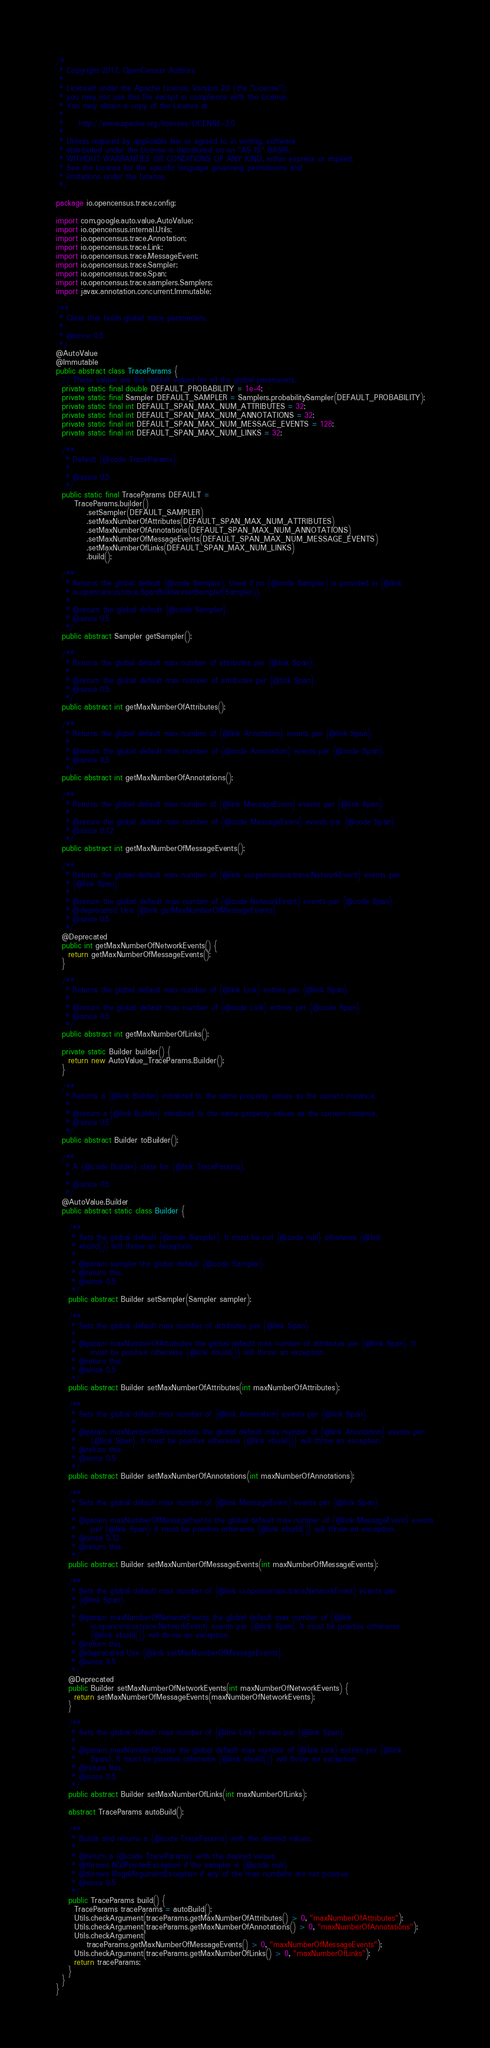<code> <loc_0><loc_0><loc_500><loc_500><_Java_>/*
 * Copyright 2017, OpenCensus Authors
 *
 * Licensed under the Apache License, Version 2.0 (the "License");
 * you may not use this file except in compliance with the License.
 * You may obtain a copy of the License at
 *
 *     http://www.apache.org/licenses/LICENSE-2.0
 *
 * Unless required by applicable law or agreed to in writing, software
 * distributed under the License is distributed on an "AS IS" BASIS,
 * WITHOUT WARRANTIES OR CONDITIONS OF ANY KIND, either express or implied.
 * See the License for the specific language governing permissions and
 * limitations under the License.
 */

package io.opencensus.trace.config;

import com.google.auto.value.AutoValue;
import io.opencensus.internal.Utils;
import io.opencensus.trace.Annotation;
import io.opencensus.trace.Link;
import io.opencensus.trace.MessageEvent;
import io.opencensus.trace.Sampler;
import io.opencensus.trace.Span;
import io.opencensus.trace.samplers.Samplers;
import javax.annotation.concurrent.Immutable;

/**
 * Class that holds global trace parameters.
 *
 * @since 0.5
 */
@AutoValue
@Immutable
public abstract class TraceParams {
  // These values are the default values for all the global parameters.
  private static final double DEFAULT_PROBABILITY = 1e-4;
  private static final Sampler DEFAULT_SAMPLER = Samplers.probabilitySampler(DEFAULT_PROBABILITY);
  private static final int DEFAULT_SPAN_MAX_NUM_ATTRIBUTES = 32;
  private static final int DEFAULT_SPAN_MAX_NUM_ANNOTATIONS = 32;
  private static final int DEFAULT_SPAN_MAX_NUM_MESSAGE_EVENTS = 128;
  private static final int DEFAULT_SPAN_MAX_NUM_LINKS = 32;

  /**
   * Default {@code TraceParams}.
   *
   * @since 0.5
   */
  public static final TraceParams DEFAULT =
      TraceParams.builder()
          .setSampler(DEFAULT_SAMPLER)
          .setMaxNumberOfAttributes(DEFAULT_SPAN_MAX_NUM_ATTRIBUTES)
          .setMaxNumberOfAnnotations(DEFAULT_SPAN_MAX_NUM_ANNOTATIONS)
          .setMaxNumberOfMessageEvents(DEFAULT_SPAN_MAX_NUM_MESSAGE_EVENTS)
          .setMaxNumberOfLinks(DEFAULT_SPAN_MAX_NUM_LINKS)
          .build();

  /**
   * Returns the global default {@code Sampler}. Used if no {@code Sampler} is provided in {@link
   * io.opencensus.trace.SpanBuilder#setSampler(Sampler)}.
   *
   * @return the global default {@code Sampler}.
   * @since 0.5
   */
  public abstract Sampler getSampler();

  /**
   * Returns the global default max number of attributes per {@link Span}.
   *
   * @return the global default max number of attributes per {@link Span}.
   * @since 0.5
   */
  public abstract int getMaxNumberOfAttributes();

  /**
   * Returns the global default max number of {@link Annotation} events per {@link Span}.
   *
   * @return the global default max number of {@code Annotation} events per {@code Span}.
   * @since 0.5
   */
  public abstract int getMaxNumberOfAnnotations();

  /**
   * Returns the global default max number of {@link MessageEvent} events per {@link Span}.
   *
   * @return the global default max number of {@code MessageEvent} events per {@code Span}.
   * @since 0.12
   */
  public abstract int getMaxNumberOfMessageEvents();

  /**
   * Returns the global default max number of {@link io.opencensus.trace.NetworkEvent} events per
   * {@link Span}.
   *
   * @return the global default max number of {@code NetworkEvent} events per {@code Span}.
   * @deprecated Use {@link getMaxNumberOfMessageEvents}.
   * @since 0.5
   */
  @Deprecated
  public int getMaxNumberOfNetworkEvents() {
    return getMaxNumberOfMessageEvents();
  }

  /**
   * Returns the global default max number of {@link Link} entries per {@link Span}.
   *
   * @return the global default max number of {@code Link} entries per {@code Span}.
   * @since 0.5
   */
  public abstract int getMaxNumberOfLinks();

  private static Builder builder() {
    return new AutoValue_TraceParams.Builder();
  }

  /**
   * Returns a {@link Builder} initialized to the same property values as the current instance.
   *
   * @return a {@link Builder} initialized to the same property values as the current instance.
   * @since 0.5
   */
  public abstract Builder toBuilder();

  /**
   * A {@code Builder} class for {@link TraceParams}.
   *
   * @since 0.5
   */
  @AutoValue.Builder
  public abstract static class Builder {

    /**
     * Sets the global default {@code Sampler}. It must be not {@code null} otherwise {@link
     * #build()} will throw an exception.
     *
     * @param sampler the global default {@code Sampler}.
     * @return this.
     * @since 0.5
     */
    public abstract Builder setSampler(Sampler sampler);

    /**
     * Sets the global default max number of attributes per {@link Span}.
     *
     * @param maxNumberOfAttributes the global default max number of attributes per {@link Span}. It
     *     must be positive otherwise {@link #build()} will throw an exception.
     * @return this.
     * @since 0.5
     */
    public abstract Builder setMaxNumberOfAttributes(int maxNumberOfAttributes);

    /**
     * Sets the global default max number of {@link Annotation} events per {@link Span}.
     *
     * @param maxNumberOfAnnotations the global default max number of {@link Annotation} events per
     *     {@link Span}. It must be positive otherwise {@link #build()} will throw an exception.
     * @return this.
     * @since 0.5
     */
    public abstract Builder setMaxNumberOfAnnotations(int maxNumberOfAnnotations);

    /**
     * Sets the global default max number of {@link MessageEvent} events per {@link Span}.
     *
     * @param maxNumberOfMessageEvents the global default max number of {@link MessageEvent} events
     *     per {@link Span}. It must be positive otherwise {@link #build()} will throw an exception.
     * @since 0.12
     * @return this.
     */
    public abstract Builder setMaxNumberOfMessageEvents(int maxNumberOfMessageEvents);

    /**
     * Sets the global default max number of {@link io.opencensus.trace.NetworkEvent} events per
     * {@link Span}.
     *
     * @param maxNumberOfNetworkEvents the global default max number of {@link
     *     io.opencensus.trace.NetworkEvent} events per {@link Span}. It must be positive otherwise
     *     {@link #build()} will throw an exception.
     * @return this.
     * @deprecated Use {@link setMaxNumberOfMessageEvents}.
     * @since 0.5
     */
    @Deprecated
    public Builder setMaxNumberOfNetworkEvents(int maxNumberOfNetworkEvents) {
      return setMaxNumberOfMessageEvents(maxNumberOfNetworkEvents);
    }

    /**
     * Sets the global default max number of {@link Link} entries per {@link Span}.
     *
     * @param maxNumberOfLinks the global default max number of {@link Link} entries per {@link
     *     Span}. It must be positive otherwise {@link #build()} will throw an exception.
     * @return this.
     * @since 0.5
     */
    public abstract Builder setMaxNumberOfLinks(int maxNumberOfLinks);

    abstract TraceParams autoBuild();

    /**
     * Builds and returns a {@code TraceParams} with the desired values.
     *
     * @return a {@code TraceParams} with the desired values.
     * @throws NullPointerException if the sampler is {@code null}.
     * @throws IllegalArgumentException if any of the max numbers are not positive.
     * @since 0.5
     */
    public TraceParams build() {
      TraceParams traceParams = autoBuild();
      Utils.checkArgument(traceParams.getMaxNumberOfAttributes() > 0, "maxNumberOfAttributes");
      Utils.checkArgument(traceParams.getMaxNumberOfAnnotations() > 0, "maxNumberOfAnnotations");
      Utils.checkArgument(
          traceParams.getMaxNumberOfMessageEvents() > 0, "maxNumberOfMessageEvents");
      Utils.checkArgument(traceParams.getMaxNumberOfLinks() > 0, "maxNumberOfLinks");
      return traceParams;
    }
  }
}
</code> 